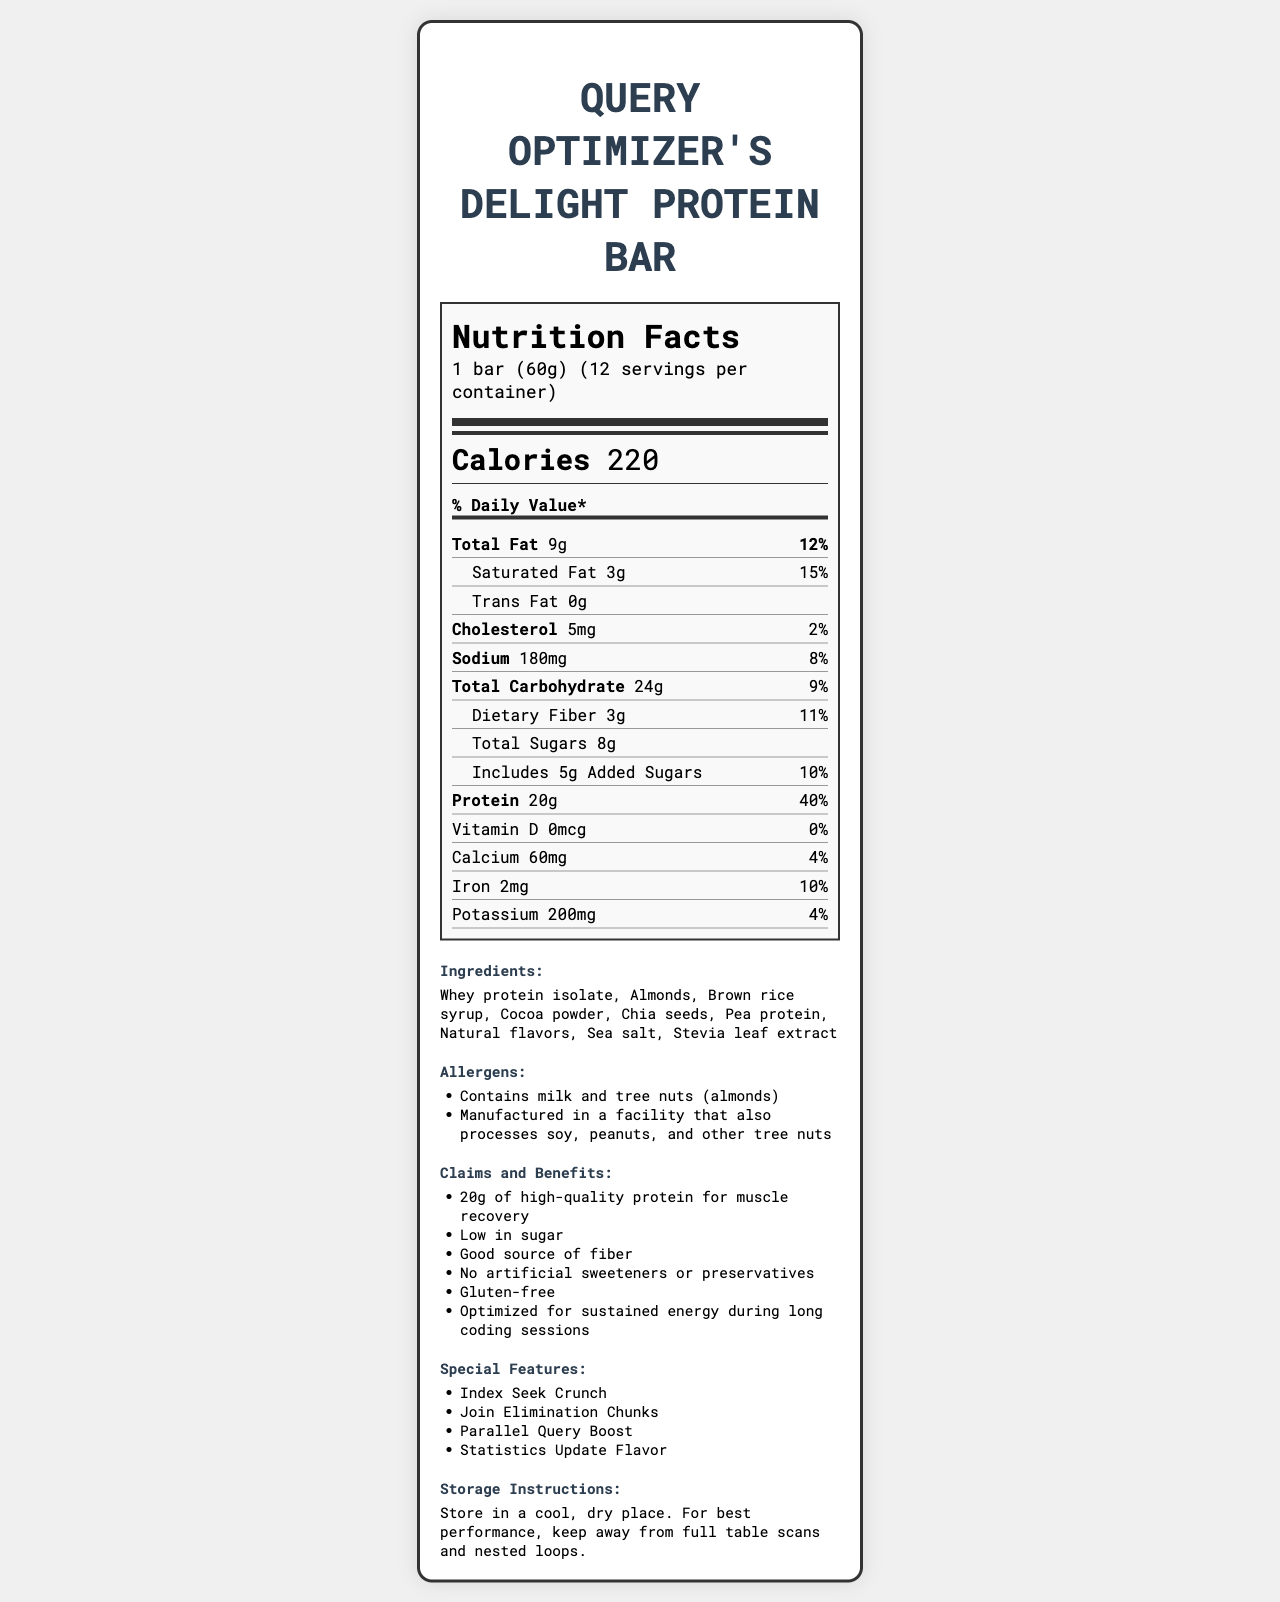What is the serving size of the Query Optimizer's Delight Protein Bar? The serving size is mentioned right at the beginning under the product name and serving information.
Answer: 1 bar (60g) How many calories are in one serving of the protein bar? The calorie content is displayed prominently in the calorie information section.
Answer: 220 What is the total fat content and its percentage daily value? This information is found in the Total Fat row under the nutrient details.
Answer: 9g, 12% How much sodium is in one serving of the protein bar? The sodium content is listed in the nutrient section with the daily value percentage next to it.
Answer: 180mg What are the primary ingredients of the protein bar? The ingredient list is clearly shown in the ingredients section towards the bottom of the document.
Answer: Whey protein isolate, Almonds, Brown rice syrup, Cocoa powder, Chia seeds, Pea protein, Natural flavors, Sea salt, Stevia leaf extract How many servings are per container of this protein bar? A. 10 B. 12 C. 14 D. 16 The number of servings per container is mentioned under the product name and serving information.
Answer: B What is the daily value percentage of dietary fiber in the protein bar? A. 9% B. 10% C. 11% D. 12% The dietary fiber daily value is given in the sub-nutrient section under Total Carbohydrate.
Answer: C Does the protein bar contain any artificial sweeteners or preservatives? (Yes/No) This information is stated in the claims and benefits section, which mentions "No artificial sweeteners or preservatives".
Answer: No What allergens are present in the Query Optimizer's Delight Protein Bar? The allergens section provides this information, with an additional note about the manufacturing facility processing.
Answer: Milk and tree nuts (almonds) Summarize the main features and benefits of the Query Optimizer's Delight Protein Bar. The detailed description of features and benefits is listed in the claims and benefits section near the bottom of the document.
Answer: The Query Optimizer's Delight Protein Bar provides 20g of high-quality protein, is low in sugar, a good source of fiber, and contains no artificial sweeteners or preservatives. It's gluten-free and optimized for sustained energy during long coding sessions. What is the price of one box of Query Optimizer's Delight Protein Bar? The price information is not available in the provided visual document.
Answer: Not enough information 